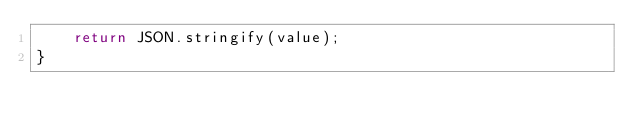<code> <loc_0><loc_0><loc_500><loc_500><_TypeScript_>    return JSON.stringify(value);
}
</code> 